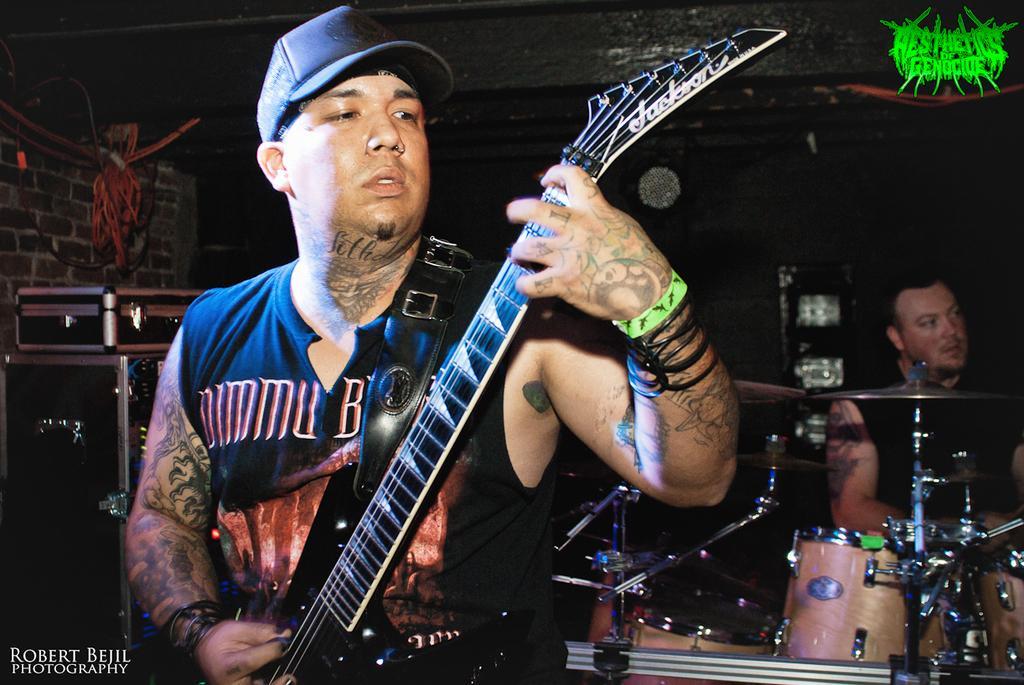Can you describe this image briefly? In this picture a tattooed guy is playing a guitar. In the background men playing musical instruments and few black sound boxes. 